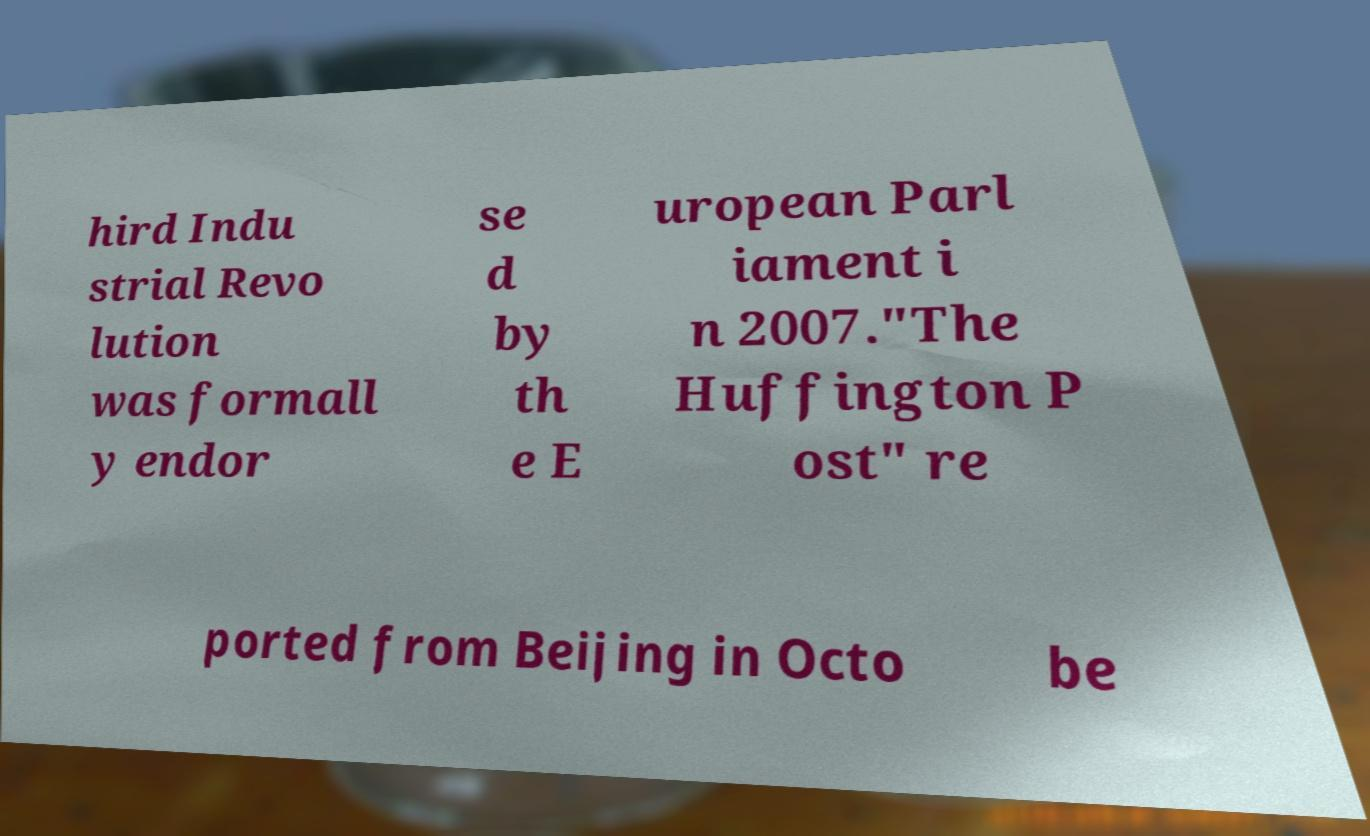Can you read and provide the text displayed in the image?This photo seems to have some interesting text. Can you extract and type it out for me? hird Indu strial Revo lution was formall y endor se d by th e E uropean Parl iament i n 2007."The Huffington P ost" re ported from Beijing in Octo be 